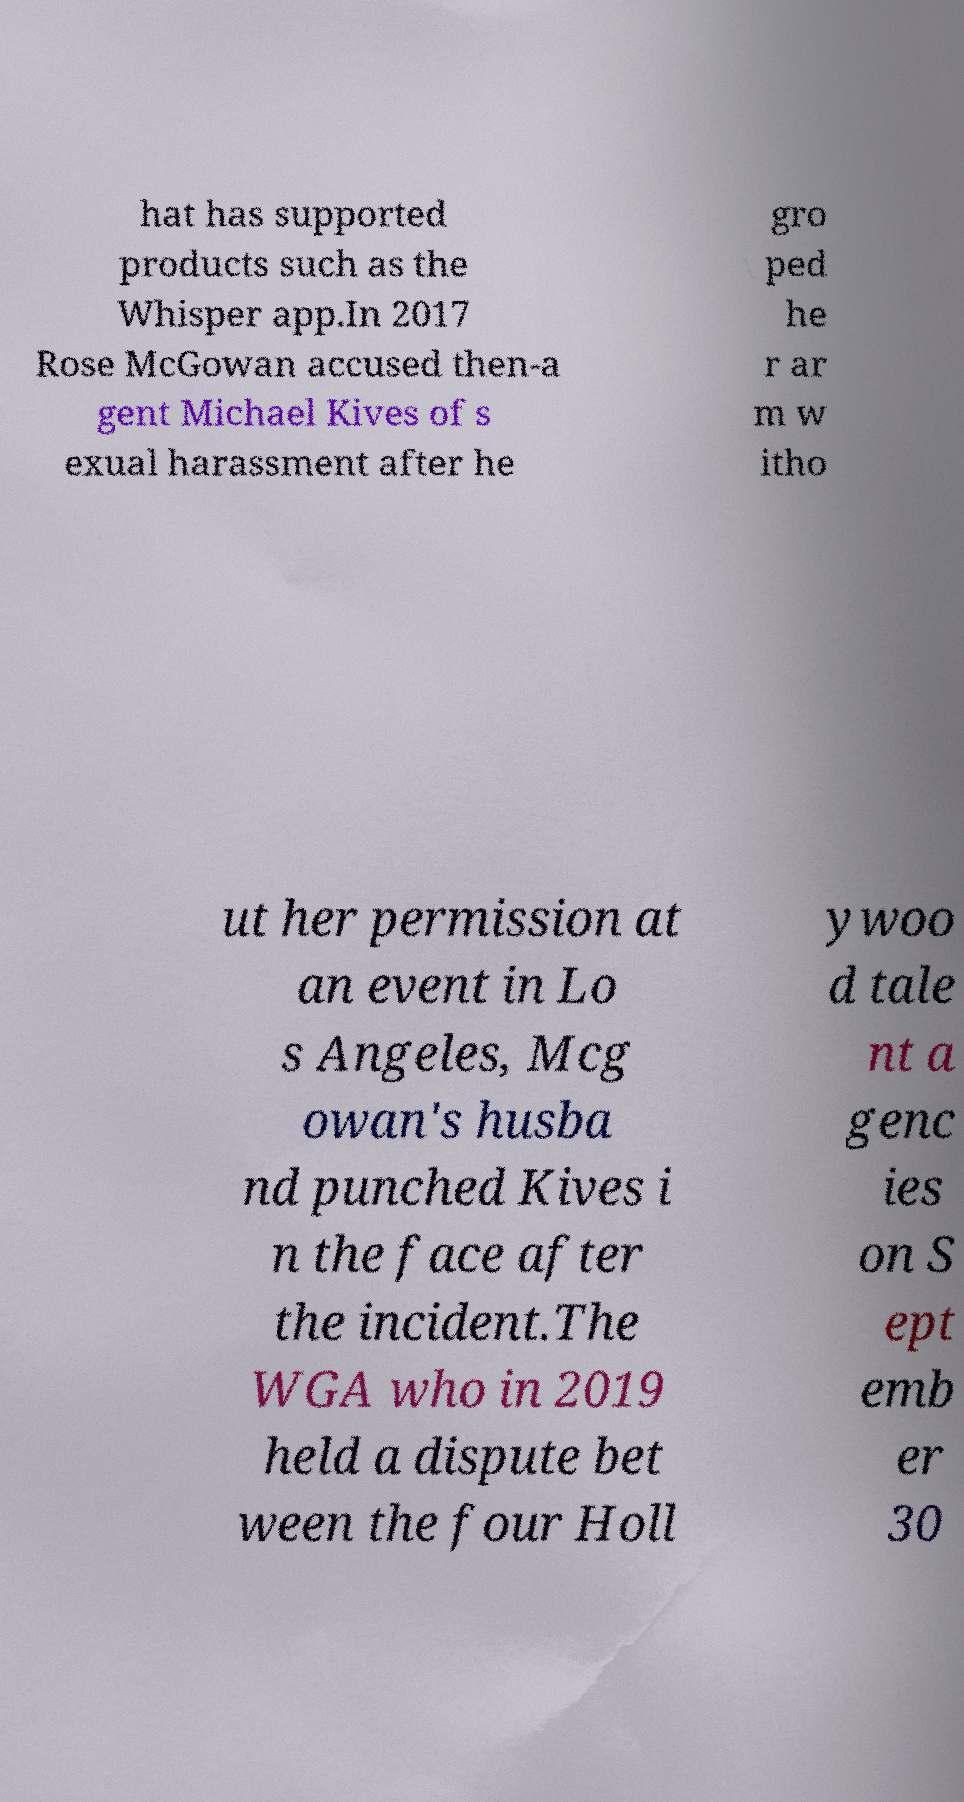Can you accurately transcribe the text from the provided image for me? hat has supported products such as the Whisper app.In 2017 Rose McGowan accused then-a gent Michael Kives of s exual harassment after he gro ped he r ar m w itho ut her permission at an event in Lo s Angeles, Mcg owan's husba nd punched Kives i n the face after the incident.The WGA who in 2019 held a dispute bet ween the four Holl ywoo d tale nt a genc ies on S ept emb er 30 